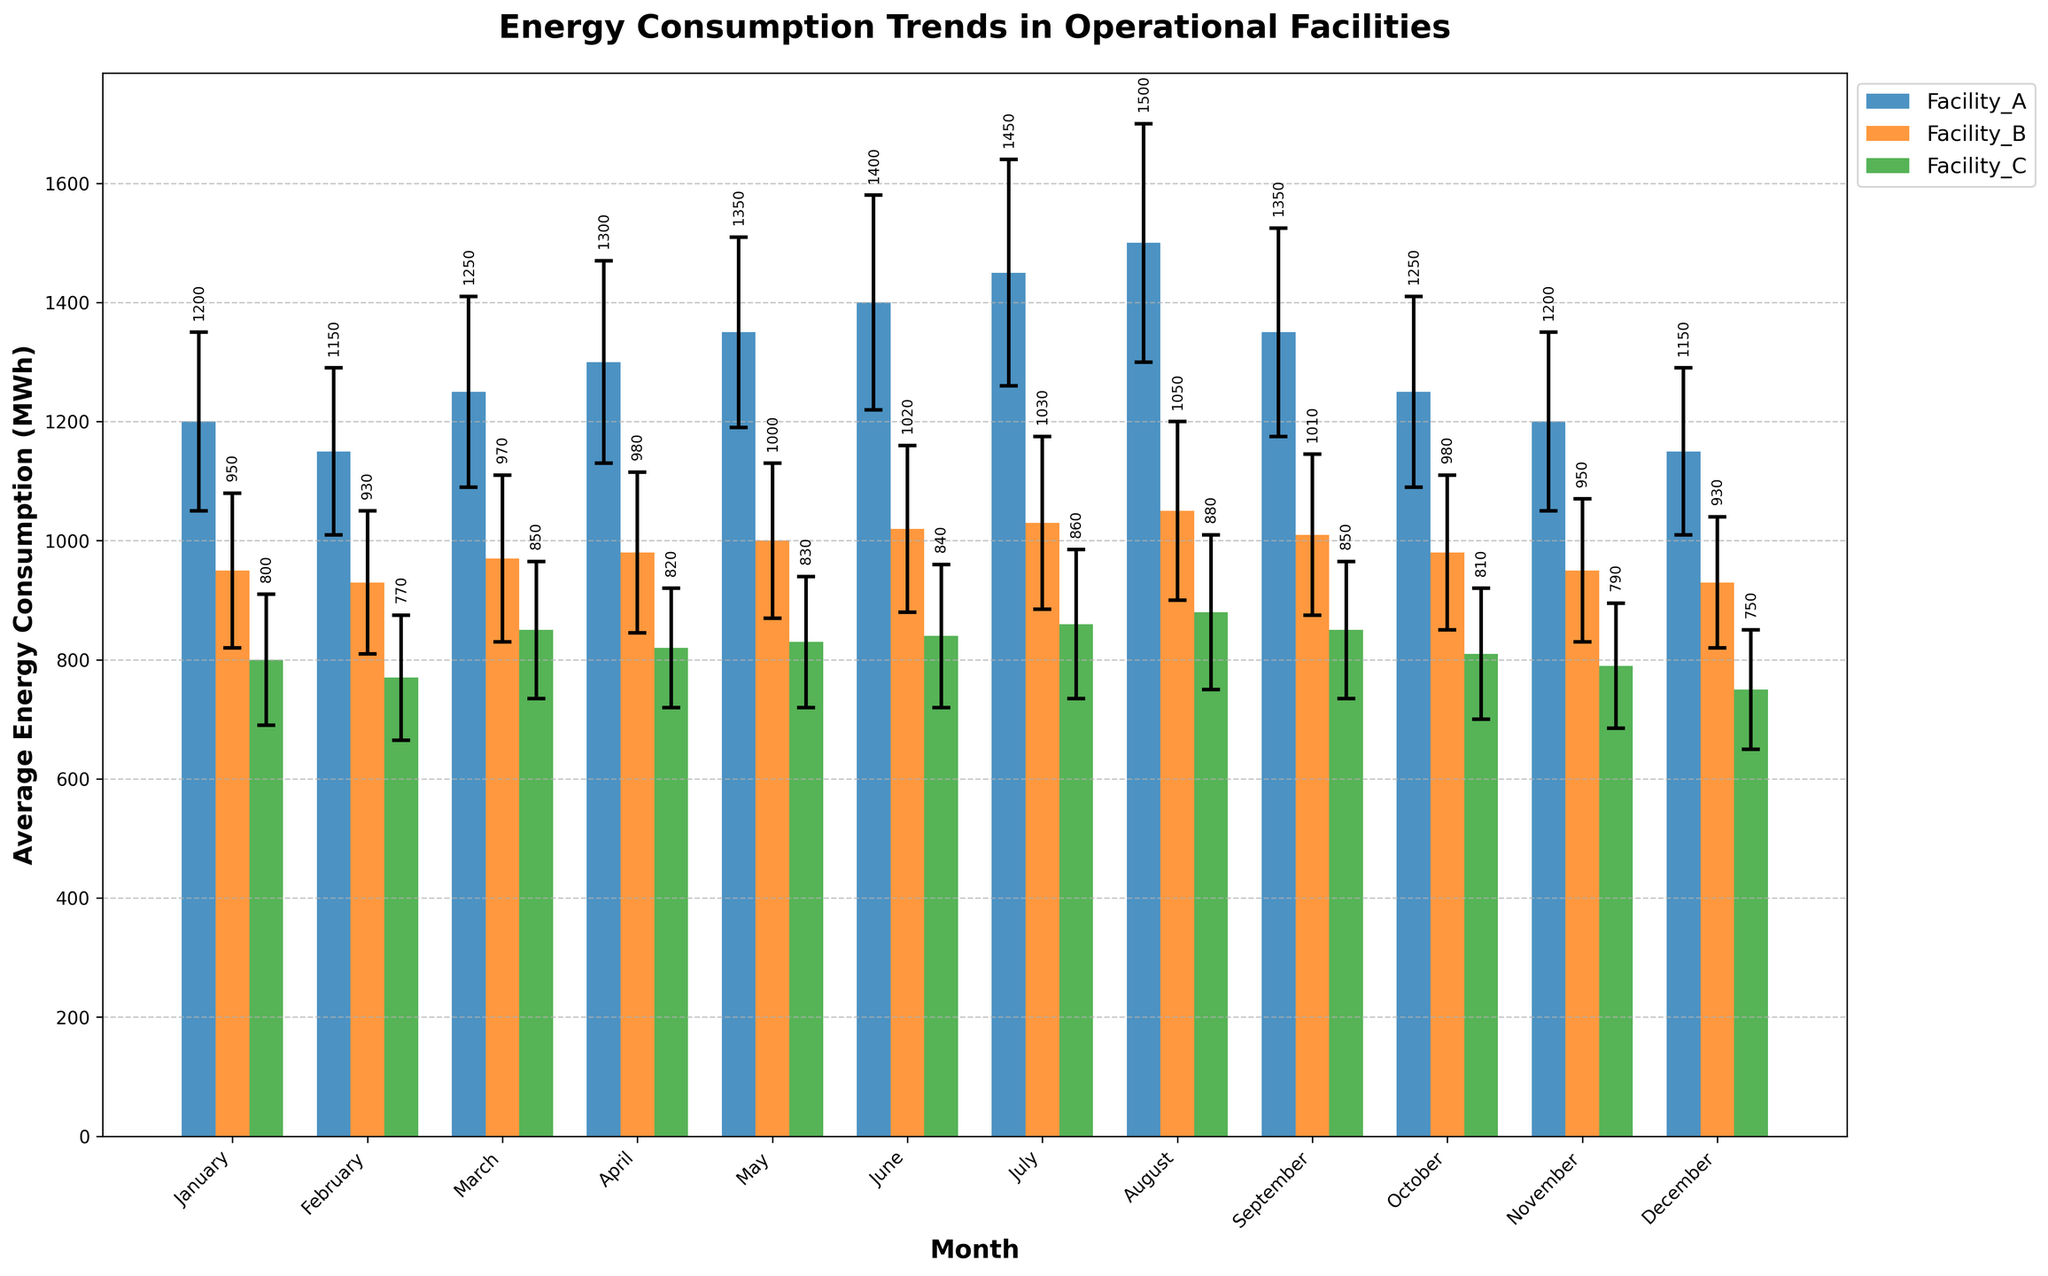What is the title of the figure? The title of the figure is displayed at the top. It reads "Energy Consumption Trends in Operational Facilities".
Answer: Energy Consumption Trends in Operational Facilities Which month had the highest average energy consumption for Facility_A? Looking at the tallest bar for Facility_A across all months, we see August has the highest average energy consumption.
Answer: August What is the value of the average energy consumption for Facility_B in November? Find the bar corresponding to Facility_B in November and read the value of the average energy consumption. It's 950 MWh.
Answer: 950 MWh Which facility had the lowest average energy consumption in June? Compare the heights of the bars for all facilities in June. Facility_C has the lowest average energy consumption.
Answer: Facility_C How much did the average energy consumption for Facility_A change from January to July? Subtract the average energy consumption in January for Facility_A (1200 MWh) from that in July (1450 MWh). The change is 1450 - 1200 = 250 MWh.
Answer: 250 MWh Which facility had the most consistent energy consumption across months, judging by the size of the error bars? The consistency of energy consumption is indicated by smaller error bars. Facility_C generally has smaller error bars compared to Facility_A and Facility_B.
Answer: Facility_C Between Facility_A and Facility_B, which had higher average energy consumption in March? Compare the heights of the bars for Facility_A and Facility_B in March. Facility_A had a higher average energy consumption.
Answer: Facility_A What was the average energy consumption of Facility_C in September, and how does it compare to its consumption in May? The average energy consumption for Facility_C in September is 850 MWh, while in May it is 830 MWh. Comparing them, September's consumption is 20 MWh higher than May's.
Answer: September: 850 MWh; May: 830 MWh; September is 20 MWh higher How much higher is the average energy consumption of Facility_A in August compared to Facility_C in the same month? Find the average energy consumption for Facility_A in August (1500 MWh) and Facility_C in August (880 MWh). The difference is 1500 - 880 = 620 MWh.
Answer: 620 MWh Which month shows the smallest average energy consumption for Facility_C? Determine the month with the shortest bar for Facility_C. December has the smallest average energy consumption for Facility_C (750 MWh).
Answer: December 